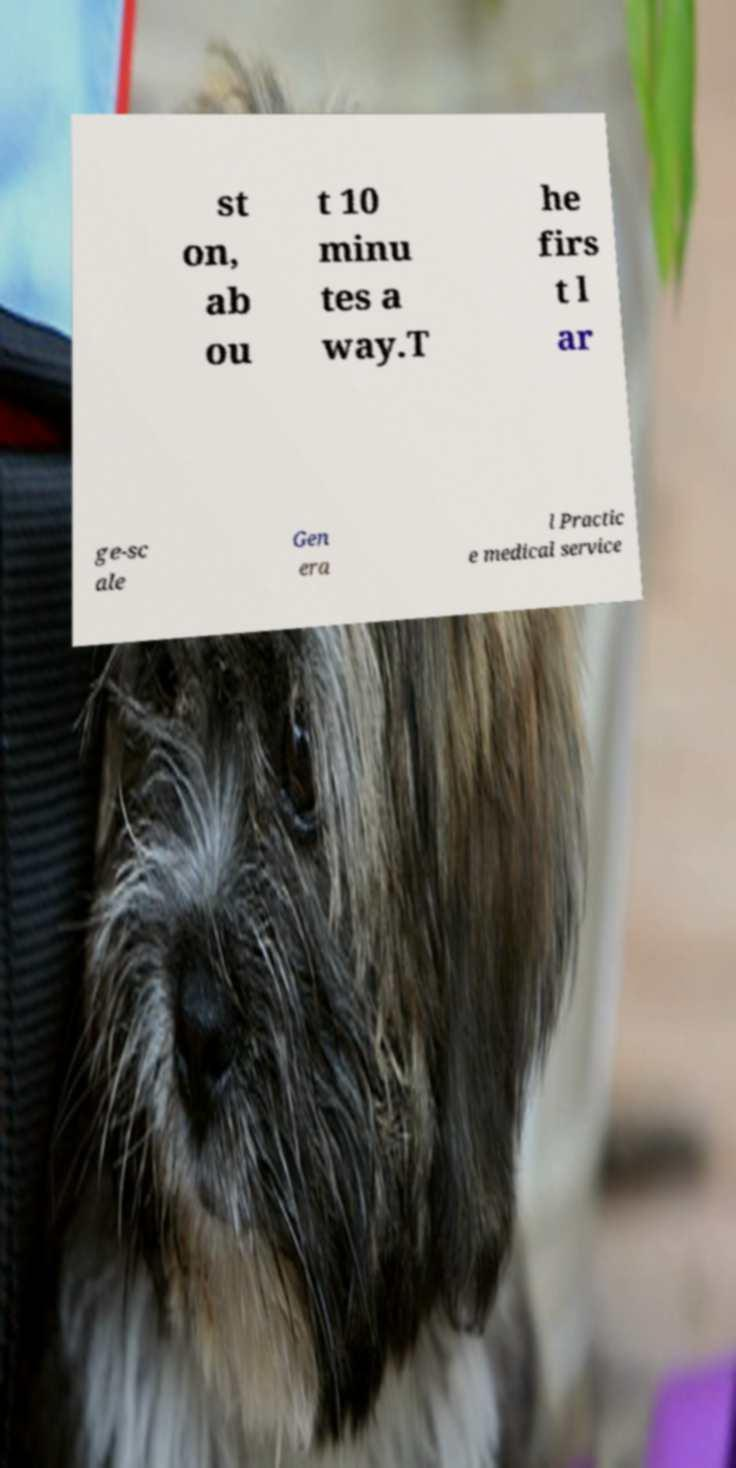What messages or text are displayed in this image? I need them in a readable, typed format. st on, ab ou t 10 minu tes a way.T he firs t l ar ge-sc ale Gen era l Practic e medical service 